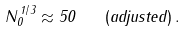<formula> <loc_0><loc_0><loc_500><loc_500>N _ { 0 } ^ { \, 1 / 3 } \approx 5 0 \quad ( a d j u s t e d ) \, .</formula> 